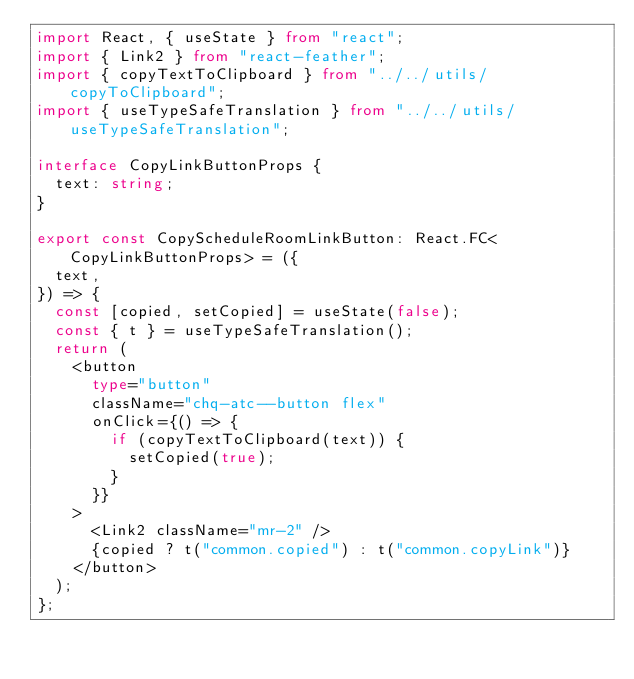Convert code to text. <code><loc_0><loc_0><loc_500><loc_500><_TypeScript_>import React, { useState } from "react";
import { Link2 } from "react-feather";
import { copyTextToClipboard } from "../../utils/copyToClipboard";
import { useTypeSafeTranslation } from "../../utils/useTypeSafeTranslation";

interface CopyLinkButtonProps {
  text: string;
}

export const CopyScheduleRoomLinkButton: React.FC<CopyLinkButtonProps> = ({
  text,
}) => {
  const [copied, setCopied] = useState(false);
  const { t } = useTypeSafeTranslation();
  return (
    <button
      type="button"
      className="chq-atc--button flex"
      onClick={() => {
        if (copyTextToClipboard(text)) {
          setCopied(true);
        }
      }}
    >
      <Link2 className="mr-2" />
      {copied ? t("common.copied") : t("common.copyLink")}
    </button>
  );
};
</code> 